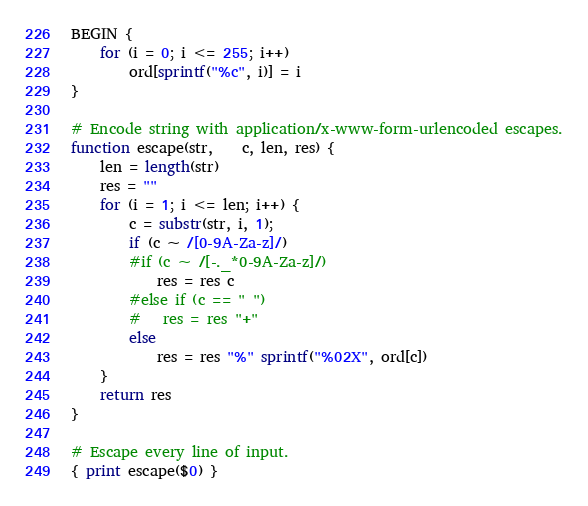Convert code to text. <code><loc_0><loc_0><loc_500><loc_500><_Awk_>BEGIN {
	for (i = 0; i <= 255; i++)
		ord[sprintf("%c", i)] = i
}

# Encode string with application/x-www-form-urlencoded escapes.
function escape(str,    c, len, res) {
	len = length(str)
	res = ""
	for (i = 1; i <= len; i++) {
		c = substr(str, i, 1);
		if (c ~ /[0-9A-Za-z]/)
		#if (c ~ /[-._*0-9A-Za-z]/)
			res = res c
		#else if (c == " ")
		#	res = res "+"
		else
			res = res "%" sprintf("%02X", ord[c])
	}
	return res
}

# Escape every line of input.
{ print escape($0) }
</code> 